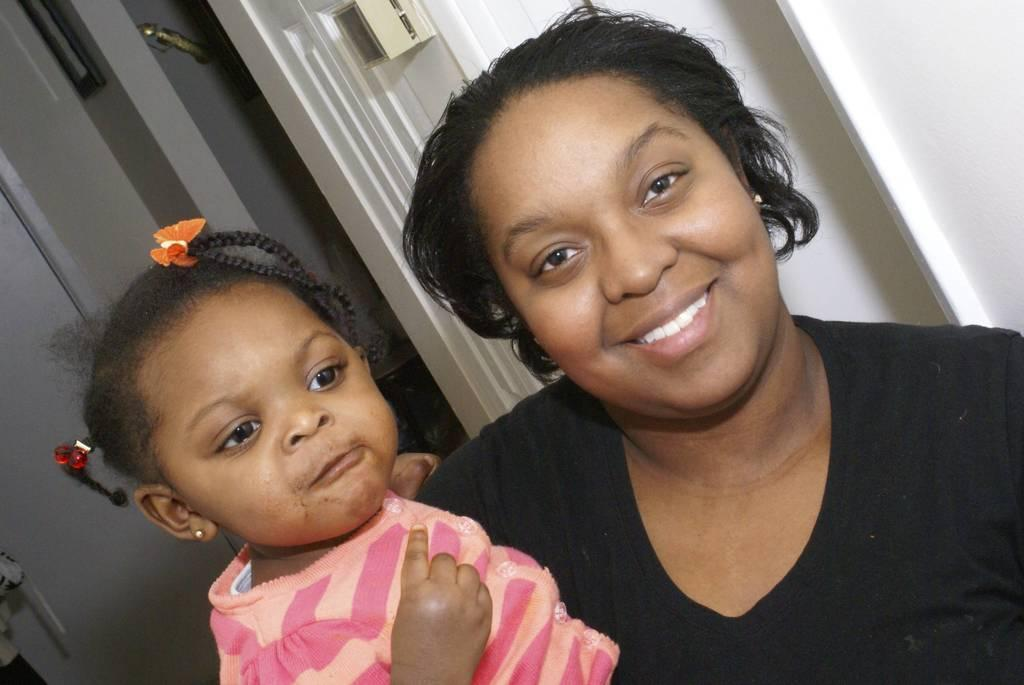Who is the main subject in the image? There is a woman in the image. What is the woman doing in the image? The woman is standing and smiling. What is the woman holding in the image? The woman is holding a kid. What can be seen in the background of the image? There is a door visible in the background of the image. How many cherries are on the woman's head in the image? There are no cherries present on the woman's head in the image. What type of curve can be seen in the image? There is no specific curve mentioned or visible in the image. 